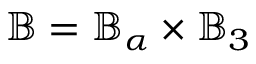<formula> <loc_0><loc_0><loc_500><loc_500>\mathbb { B } = \mathbb { B } _ { \alpha } \times \mathbb { B } _ { 3 }</formula> 